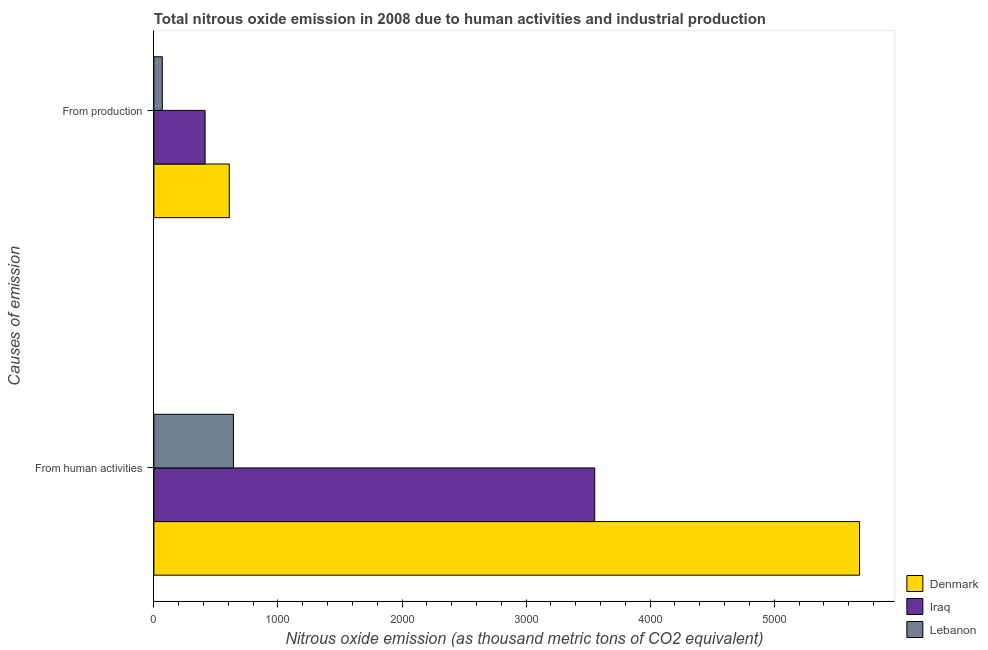How many different coloured bars are there?
Your answer should be compact. 3. What is the label of the 1st group of bars from the top?
Offer a very short reply. From production. Across all countries, what is the maximum amount of emissions from human activities?
Ensure brevity in your answer.  5688.2. In which country was the amount of emissions generated from industries minimum?
Keep it short and to the point. Lebanon. What is the total amount of emissions from human activities in the graph?
Your response must be concise. 9883.2. What is the difference between the amount of emissions generated from industries in Iraq and that in Lebanon?
Offer a terse response. 344.8. What is the difference between the amount of emissions from human activities in Iraq and the amount of emissions generated from industries in Denmark?
Provide a succinct answer. 2945.6. What is the average amount of emissions generated from industries per country?
Provide a succinct answer. 362.87. What is the difference between the amount of emissions generated from industries and amount of emissions from human activities in Denmark?
Your response must be concise. -5080.4. In how many countries, is the amount of emissions generated from industries greater than 4800 thousand metric tons?
Your response must be concise. 0. What is the ratio of the amount of emissions generated from industries in Lebanon to that in Iraq?
Offer a terse response. 0.16. Is the amount of emissions from human activities in Denmark less than that in Iraq?
Keep it short and to the point. No. In how many countries, is the amount of emissions from human activities greater than the average amount of emissions from human activities taken over all countries?
Make the answer very short. 2. What does the 1st bar from the top in From human activities represents?
Make the answer very short. Lebanon. What does the 2nd bar from the bottom in From production represents?
Your response must be concise. Iraq. How many bars are there?
Make the answer very short. 6. Are all the bars in the graph horizontal?
Your answer should be very brief. Yes. What is the difference between two consecutive major ticks on the X-axis?
Your answer should be compact. 1000. Are the values on the major ticks of X-axis written in scientific E-notation?
Give a very brief answer. No. Does the graph contain grids?
Your answer should be compact. No. Where does the legend appear in the graph?
Provide a succinct answer. Bottom right. How many legend labels are there?
Your response must be concise. 3. How are the legend labels stacked?
Your answer should be compact. Vertical. What is the title of the graph?
Your answer should be compact. Total nitrous oxide emission in 2008 due to human activities and industrial production. What is the label or title of the X-axis?
Offer a very short reply. Nitrous oxide emission (as thousand metric tons of CO2 equivalent). What is the label or title of the Y-axis?
Your answer should be compact. Causes of emission. What is the Nitrous oxide emission (as thousand metric tons of CO2 equivalent) in Denmark in From human activities?
Provide a succinct answer. 5688.2. What is the Nitrous oxide emission (as thousand metric tons of CO2 equivalent) in Iraq in From human activities?
Your response must be concise. 3553.4. What is the Nitrous oxide emission (as thousand metric tons of CO2 equivalent) in Lebanon in From human activities?
Your answer should be compact. 641.6. What is the Nitrous oxide emission (as thousand metric tons of CO2 equivalent) of Denmark in From production?
Your response must be concise. 607.8. What is the Nitrous oxide emission (as thousand metric tons of CO2 equivalent) in Iraq in From production?
Your response must be concise. 412.8. Across all Causes of emission, what is the maximum Nitrous oxide emission (as thousand metric tons of CO2 equivalent) of Denmark?
Make the answer very short. 5688.2. Across all Causes of emission, what is the maximum Nitrous oxide emission (as thousand metric tons of CO2 equivalent) in Iraq?
Ensure brevity in your answer.  3553.4. Across all Causes of emission, what is the maximum Nitrous oxide emission (as thousand metric tons of CO2 equivalent) in Lebanon?
Provide a short and direct response. 641.6. Across all Causes of emission, what is the minimum Nitrous oxide emission (as thousand metric tons of CO2 equivalent) of Denmark?
Ensure brevity in your answer.  607.8. Across all Causes of emission, what is the minimum Nitrous oxide emission (as thousand metric tons of CO2 equivalent) in Iraq?
Offer a terse response. 412.8. Across all Causes of emission, what is the minimum Nitrous oxide emission (as thousand metric tons of CO2 equivalent) in Lebanon?
Your answer should be very brief. 68. What is the total Nitrous oxide emission (as thousand metric tons of CO2 equivalent) in Denmark in the graph?
Your answer should be compact. 6296. What is the total Nitrous oxide emission (as thousand metric tons of CO2 equivalent) in Iraq in the graph?
Provide a short and direct response. 3966.2. What is the total Nitrous oxide emission (as thousand metric tons of CO2 equivalent) in Lebanon in the graph?
Keep it short and to the point. 709.6. What is the difference between the Nitrous oxide emission (as thousand metric tons of CO2 equivalent) in Denmark in From human activities and that in From production?
Offer a terse response. 5080.4. What is the difference between the Nitrous oxide emission (as thousand metric tons of CO2 equivalent) in Iraq in From human activities and that in From production?
Your response must be concise. 3140.6. What is the difference between the Nitrous oxide emission (as thousand metric tons of CO2 equivalent) in Lebanon in From human activities and that in From production?
Provide a short and direct response. 573.6. What is the difference between the Nitrous oxide emission (as thousand metric tons of CO2 equivalent) of Denmark in From human activities and the Nitrous oxide emission (as thousand metric tons of CO2 equivalent) of Iraq in From production?
Make the answer very short. 5275.4. What is the difference between the Nitrous oxide emission (as thousand metric tons of CO2 equivalent) in Denmark in From human activities and the Nitrous oxide emission (as thousand metric tons of CO2 equivalent) in Lebanon in From production?
Offer a very short reply. 5620.2. What is the difference between the Nitrous oxide emission (as thousand metric tons of CO2 equivalent) in Iraq in From human activities and the Nitrous oxide emission (as thousand metric tons of CO2 equivalent) in Lebanon in From production?
Offer a terse response. 3485.4. What is the average Nitrous oxide emission (as thousand metric tons of CO2 equivalent) in Denmark per Causes of emission?
Make the answer very short. 3148. What is the average Nitrous oxide emission (as thousand metric tons of CO2 equivalent) in Iraq per Causes of emission?
Your response must be concise. 1983.1. What is the average Nitrous oxide emission (as thousand metric tons of CO2 equivalent) in Lebanon per Causes of emission?
Provide a short and direct response. 354.8. What is the difference between the Nitrous oxide emission (as thousand metric tons of CO2 equivalent) in Denmark and Nitrous oxide emission (as thousand metric tons of CO2 equivalent) in Iraq in From human activities?
Provide a short and direct response. 2134.8. What is the difference between the Nitrous oxide emission (as thousand metric tons of CO2 equivalent) in Denmark and Nitrous oxide emission (as thousand metric tons of CO2 equivalent) in Lebanon in From human activities?
Keep it short and to the point. 5046.6. What is the difference between the Nitrous oxide emission (as thousand metric tons of CO2 equivalent) in Iraq and Nitrous oxide emission (as thousand metric tons of CO2 equivalent) in Lebanon in From human activities?
Your answer should be very brief. 2911.8. What is the difference between the Nitrous oxide emission (as thousand metric tons of CO2 equivalent) of Denmark and Nitrous oxide emission (as thousand metric tons of CO2 equivalent) of Iraq in From production?
Offer a terse response. 195. What is the difference between the Nitrous oxide emission (as thousand metric tons of CO2 equivalent) in Denmark and Nitrous oxide emission (as thousand metric tons of CO2 equivalent) in Lebanon in From production?
Offer a very short reply. 539.8. What is the difference between the Nitrous oxide emission (as thousand metric tons of CO2 equivalent) of Iraq and Nitrous oxide emission (as thousand metric tons of CO2 equivalent) of Lebanon in From production?
Ensure brevity in your answer.  344.8. What is the ratio of the Nitrous oxide emission (as thousand metric tons of CO2 equivalent) in Denmark in From human activities to that in From production?
Provide a succinct answer. 9.36. What is the ratio of the Nitrous oxide emission (as thousand metric tons of CO2 equivalent) in Iraq in From human activities to that in From production?
Offer a terse response. 8.61. What is the ratio of the Nitrous oxide emission (as thousand metric tons of CO2 equivalent) of Lebanon in From human activities to that in From production?
Provide a succinct answer. 9.44. What is the difference between the highest and the second highest Nitrous oxide emission (as thousand metric tons of CO2 equivalent) in Denmark?
Offer a terse response. 5080.4. What is the difference between the highest and the second highest Nitrous oxide emission (as thousand metric tons of CO2 equivalent) of Iraq?
Provide a succinct answer. 3140.6. What is the difference between the highest and the second highest Nitrous oxide emission (as thousand metric tons of CO2 equivalent) of Lebanon?
Give a very brief answer. 573.6. What is the difference between the highest and the lowest Nitrous oxide emission (as thousand metric tons of CO2 equivalent) of Denmark?
Give a very brief answer. 5080.4. What is the difference between the highest and the lowest Nitrous oxide emission (as thousand metric tons of CO2 equivalent) in Iraq?
Keep it short and to the point. 3140.6. What is the difference between the highest and the lowest Nitrous oxide emission (as thousand metric tons of CO2 equivalent) of Lebanon?
Provide a succinct answer. 573.6. 